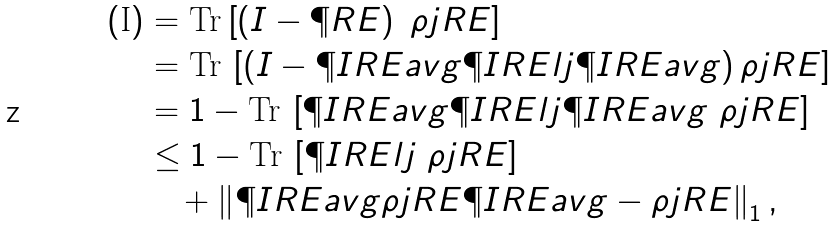Convert formula to latex. <formula><loc_0><loc_0><loc_500><loc_500>( \text {I} ) & = \text {Tr} \left [ \left ( I - \P R E \right ) \ \rho j R E \right ] \\ & = \text {Tr} \, \left [ \left ( I - \P I R E a v g \P I R E l j \P I R E a v g \right ) \rho j R E \right ] \\ & = 1 - \text {Tr} \, \left [ \P I R E a v g \P I R E l j \P I R E a v g \ \rho j R E \right ] \\ & \leq 1 - \text {Tr} \, \left [ \P I R E l j \ \rho j R E \right ] \\ & \quad + \left \| \P I R E a v g \rho j R E \P I R E a v g - \rho j R E \right \| _ { 1 } ,</formula> 